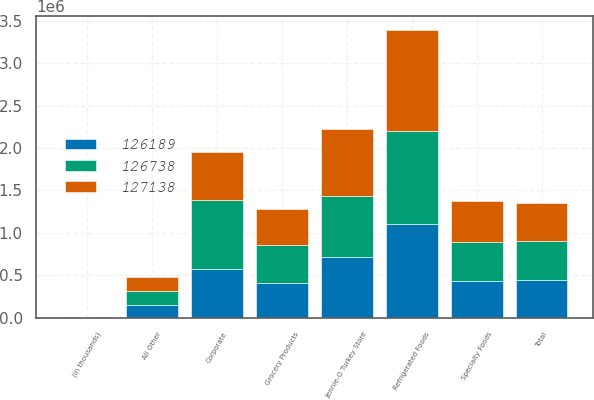Convert chart to OTSL. <chart><loc_0><loc_0><loc_500><loc_500><stacked_bar_chart><ecel><fcel>(in thousands)<fcel>Grocery Products<fcel>Refrigerated Foods<fcel>Jennie-O Turkey Store<fcel>Specialty Foods<fcel>All Other<fcel>Corporate<fcel>Total<nl><fcel>126738<fcel>2009<fcel>445340<fcel>1.09813e+06<fcel>728049<fcel>449558<fcel>163611<fcel>807364<fcel>449558<nl><fcel>127138<fcel>2008<fcel>425798<fcel>1.18978e+06<fcel>779755<fcel>487681<fcel>168012<fcel>565442<fcel>449558<nl><fcel>126189<fcel>2007<fcel>414377<fcel>1.10039e+06<fcel>711399<fcel>438836<fcel>149181<fcel>579463<fcel>449558<nl></chart> 